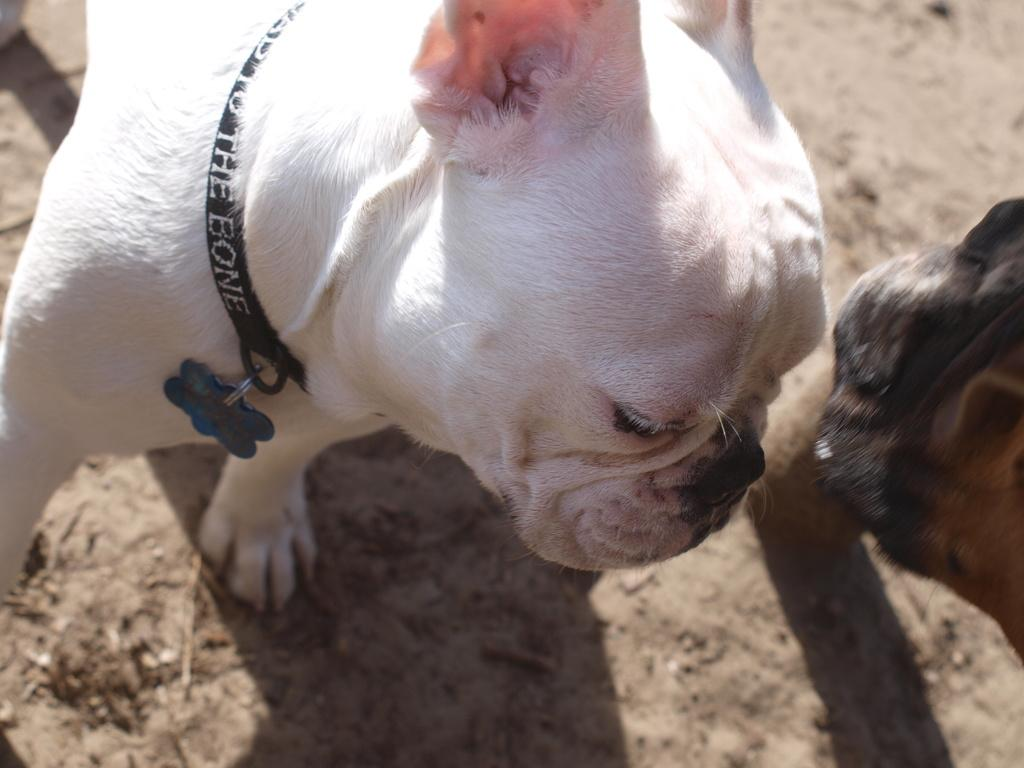What type of creatures are present in the image? There are animals in the image. Where are the animals located? The animals are on the ground. Can you describe any specific features of the animals? There is text visible on a belt of a white animal. Is the owner of the animals visible in the image? There is no owner visible in the image; it only shows the animals on the ground. Can you describe the stream where the animals are running? There is no stream present in the image, nor are the animals running. 